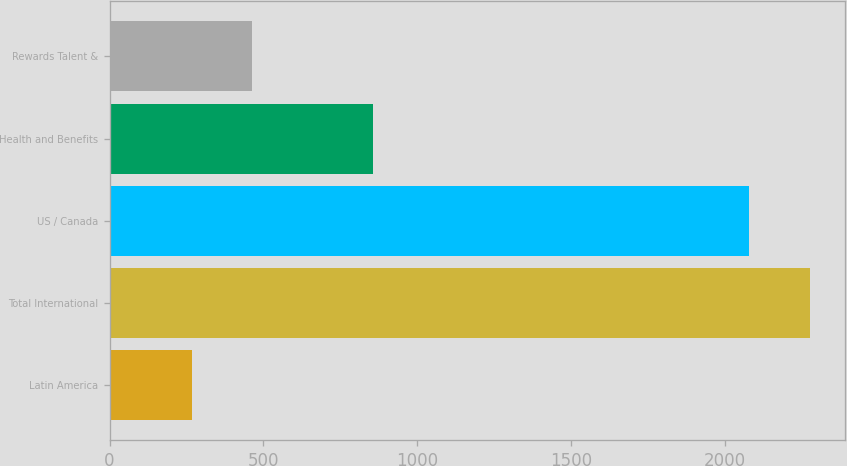<chart> <loc_0><loc_0><loc_500><loc_500><bar_chart><fcel>Latin America<fcel>Total International<fcel>US / Canada<fcel>Health and Benefits<fcel>Rewards Talent &<nl><fcel>267<fcel>2275.4<fcel>2078<fcel>857<fcel>464.4<nl></chart> 